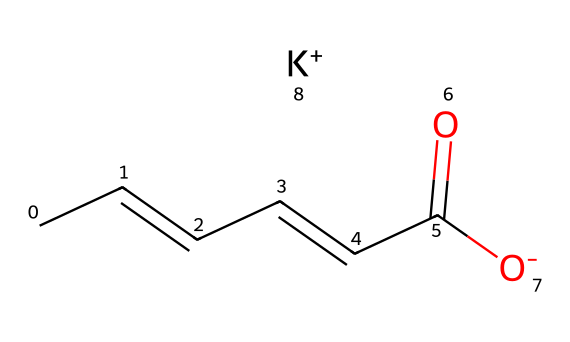What is the total number of carbon atoms in potassium sorbate? The SMILES representation indicates a chain of carbon atoms followed by a carboxylate group. Counting the 'C' characters in the SMILES yields a total of 6 carbon atoms.
Answer: 6 How many oxygen atoms are present in potassium sorbate? In the SMILES, there are two oxygen atoms represented by the 'O' characters (one in the carboxylate group and one in the carbonyl). Therefore, the total count is 2.
Answer: 2 Is potassium sorbate an ionic or covalent compound? The presence of the potassium ion (K+) alongside the negatively charged sorbate suggests that this is an ionic compound, where the potassium ion is paired with the sorbate anion.
Answer: ionic What functional group is present in potassium sorbate? The chemical structure indicates a carboxylate functional group (-COO-) located at the end of the carbon chain, characterized by the carbon double-bonded to one oxygen and single-bonded to another oxygen.
Answer: carboxylate How many double bonds are in the potassium sorbate structure? Examining the SMILES shows one double bond in the carbon chain (C=C) and one double bond in the carbonyl (C=O), totaling two double bonds.
Answer: 2 What property of potassium sorbate makes it useful as a preservative? Its ability to inhibit the growth of mold and yeast is due to its molecular structure, which disrupts cellular processes in these organisms. This function aligns with its role as a food preservative.
Answer: antimicrobial What is the charge of the potassium ion in this compound? The ‘K+’ in the SMILES indicates that the potassium ion has a positive charge, which suggests it acts as a cation in this ionic compound.
Answer: +1 